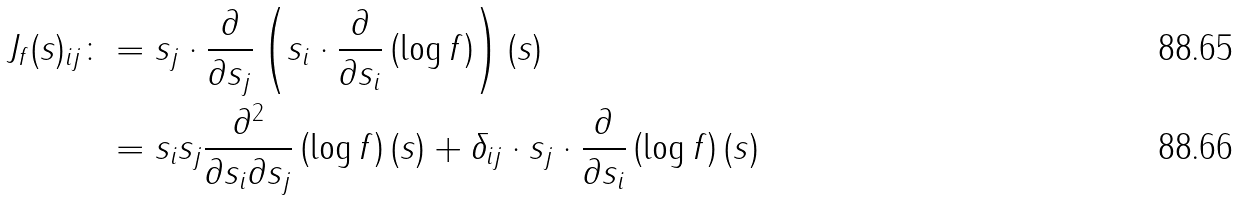<formula> <loc_0><loc_0><loc_500><loc_500>J _ { f } ( s ) _ { i j } \colon & = s _ { j } \cdot \frac { \partial } { \partial s _ { j } } \left ( s _ { i } \cdot \frac { \partial } { \partial s _ { i } } \left ( \log f \right ) \right ) ( s ) \\ & = s _ { i } s _ { j } \frac { \partial ^ { 2 } } { \partial s _ { i } \partial s _ { j } } \left ( \log f \right ) ( s ) + \delta _ { i j } \cdot s _ { j } \cdot \frac { \partial } { \partial s _ { i } } \left ( \log f \right ) ( s )</formula> 